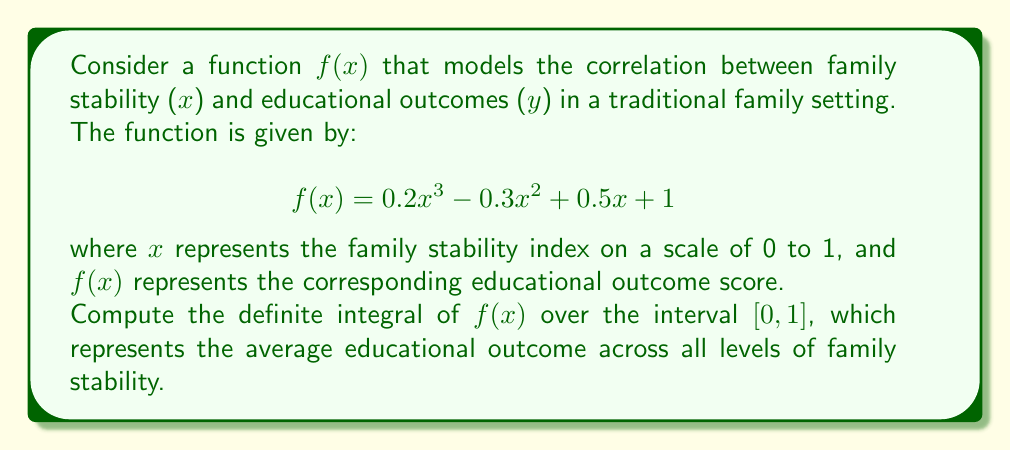Teach me how to tackle this problem. To solve this problem, we need to integrate the given function $f(x)$ over the interval $[0,1]$. Let's break it down step by step:

1) The integral we need to compute is:

   $$\int_0^1 (0.2x^3 - 0.3x^2 + 0.5x + 1) dx$$

2) Let's integrate each term separately:

   a) $\int 0.2x^3 dx = 0.2 \cdot \frac{x^4}{4} = 0.05x^4$
   b) $\int -0.3x^2 dx = -0.3 \cdot \frac{x^3}{3} = -0.1x^3$
   c) $\int 0.5x dx = 0.5 \cdot \frac{x^2}{2} = 0.25x^2$
   d) $\int 1 dx = x$

3) Combining these results, we get the antiderivative:

   $$F(x) = 0.05x^4 - 0.1x^3 + 0.25x^2 + x + C$$

4) Now we apply the fundamental theorem of calculus:

   $$\int_0^1 f(x) dx = F(1) - F(0)$$

5) Let's calculate $F(1)$ and $F(0)$:

   $F(1) = 0.05(1)^4 - 0.1(1)^3 + 0.25(1)^2 + 1 + C = 0.05 - 0.1 + 0.25 + 1 + C = 1.2 + C$

   $F(0) = 0.05(0)^4 - 0.1(0)^3 + 0.25(0)^2 + 0 + C = C$

6) Subtracting:

   $$F(1) - F(0) = (1.2 + C) - C = 1.2$$

Therefore, the definite integral of $f(x)$ over the interval $[0,1]$ is 1.2.
Answer: 1.2 